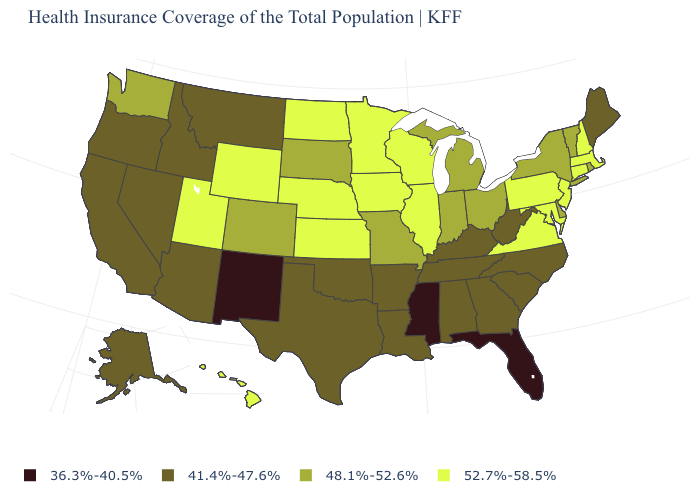What is the value of Idaho?
Keep it brief. 41.4%-47.6%. What is the value of West Virginia?
Keep it brief. 41.4%-47.6%. Which states hav the highest value in the MidWest?
Concise answer only. Illinois, Iowa, Kansas, Minnesota, Nebraska, North Dakota, Wisconsin. What is the value of Maryland?
Short answer required. 52.7%-58.5%. Is the legend a continuous bar?
Answer briefly. No. Which states have the lowest value in the USA?
Be succinct. Florida, Mississippi, New Mexico. Among the states that border Kentucky , does Ohio have the lowest value?
Quick response, please. No. Which states hav the highest value in the South?
Concise answer only. Maryland, Virginia. Does Florida have the lowest value in the USA?
Quick response, please. Yes. What is the value of Kentucky?
Give a very brief answer. 41.4%-47.6%. What is the value of Georgia?
Answer briefly. 41.4%-47.6%. What is the value of Alaska?
Short answer required. 41.4%-47.6%. What is the value of Ohio?
Give a very brief answer. 48.1%-52.6%. What is the value of Idaho?
Short answer required. 41.4%-47.6%. What is the value of Iowa?
Concise answer only. 52.7%-58.5%. 